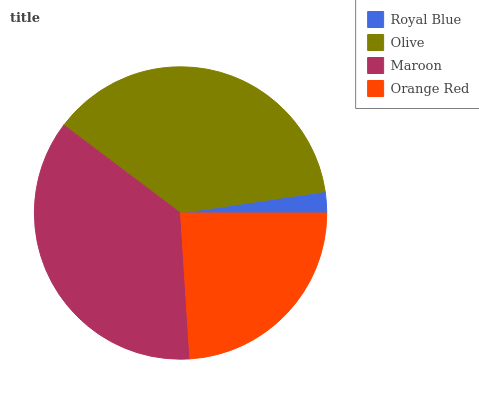Is Royal Blue the minimum?
Answer yes or no. Yes. Is Olive the maximum?
Answer yes or no. Yes. Is Maroon the minimum?
Answer yes or no. No. Is Maroon the maximum?
Answer yes or no. No. Is Olive greater than Maroon?
Answer yes or no. Yes. Is Maroon less than Olive?
Answer yes or no. Yes. Is Maroon greater than Olive?
Answer yes or no. No. Is Olive less than Maroon?
Answer yes or no. No. Is Maroon the high median?
Answer yes or no. Yes. Is Orange Red the low median?
Answer yes or no. Yes. Is Royal Blue the high median?
Answer yes or no. No. Is Maroon the low median?
Answer yes or no. No. 